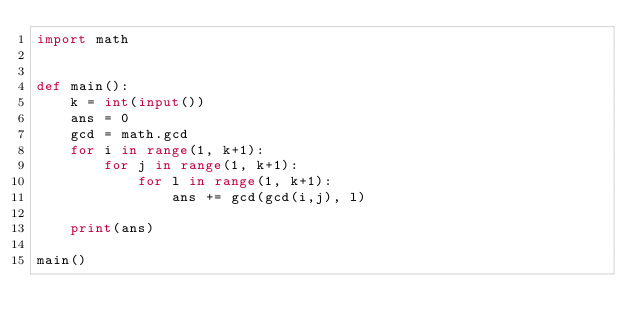<code> <loc_0><loc_0><loc_500><loc_500><_Python_>import math


def main():
    k = int(input())
    ans = 0
    gcd = math.gcd
    for i in range(1, k+1):
        for j in range(1, k+1):
            for l in range(1, k+1):
                ans += gcd(gcd(i,j), l)

    print(ans)

main()</code> 